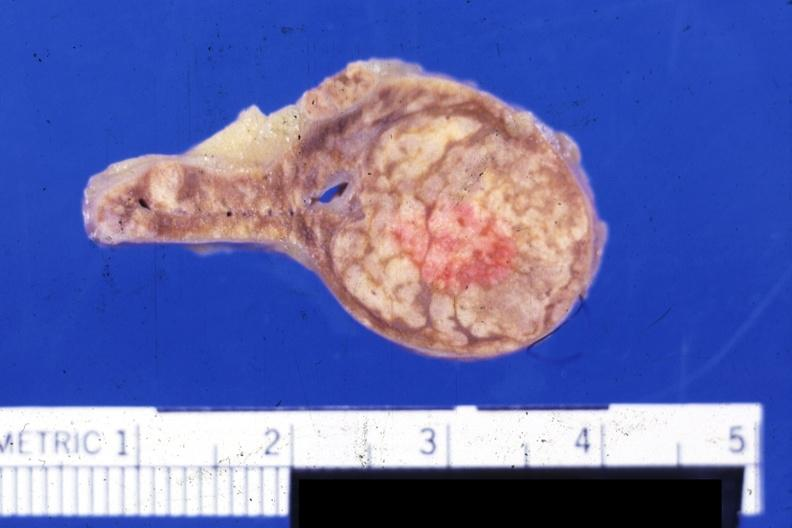where does this belong to?
Answer the question using a single word or phrase. Endocrine system 